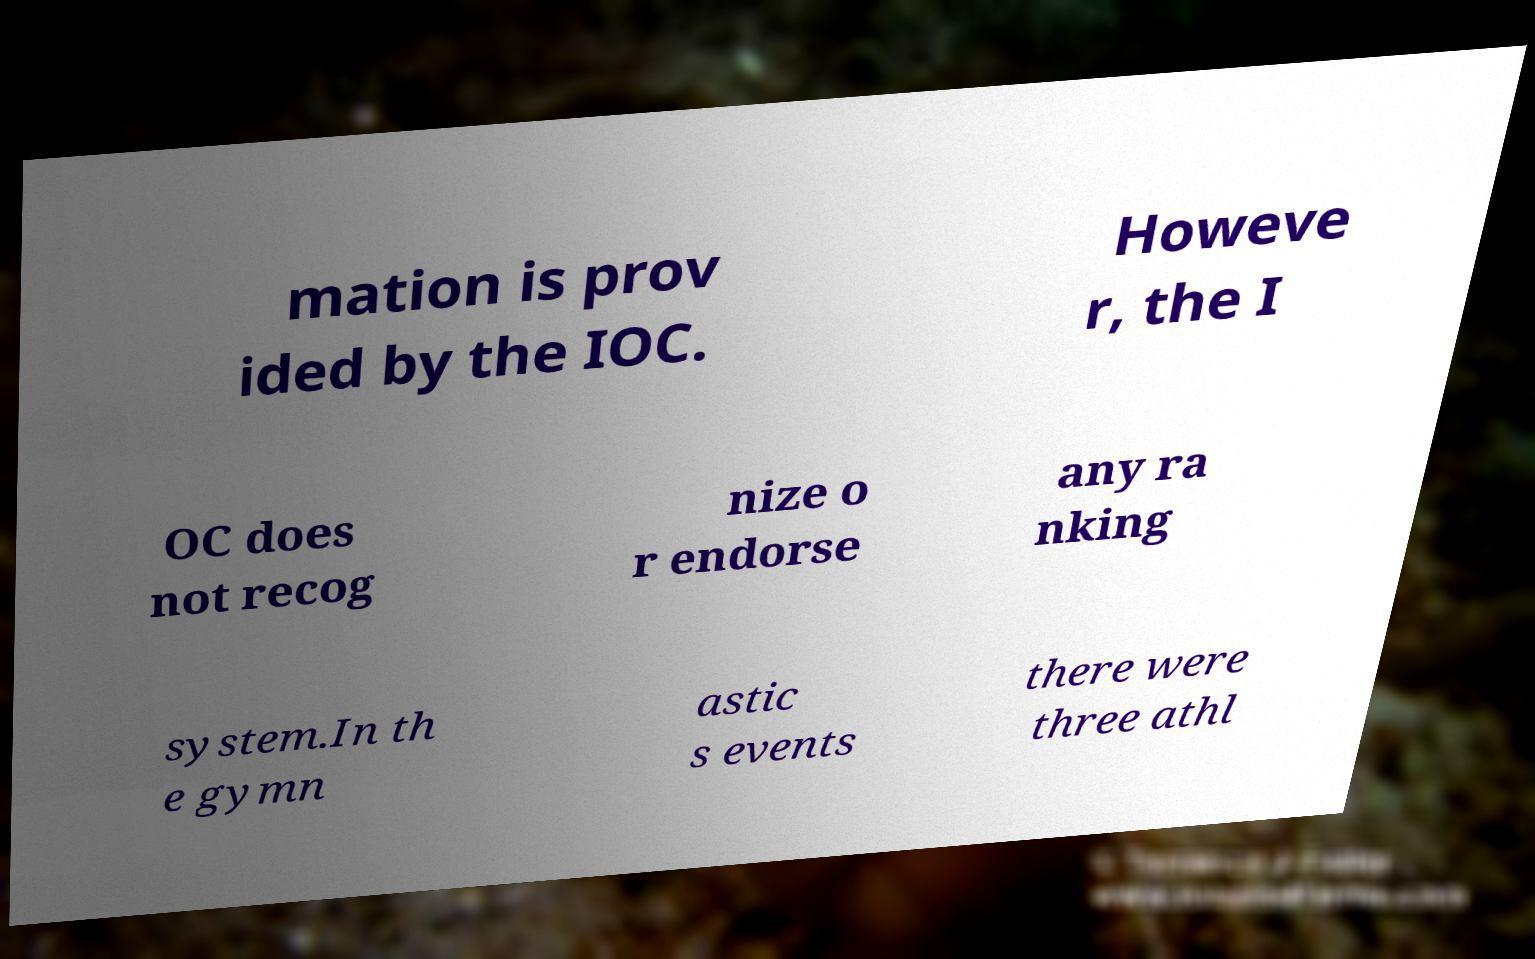There's text embedded in this image that I need extracted. Can you transcribe it verbatim? mation is prov ided by the IOC. Howeve r, the I OC does not recog nize o r endorse any ra nking system.In th e gymn astic s events there were three athl 